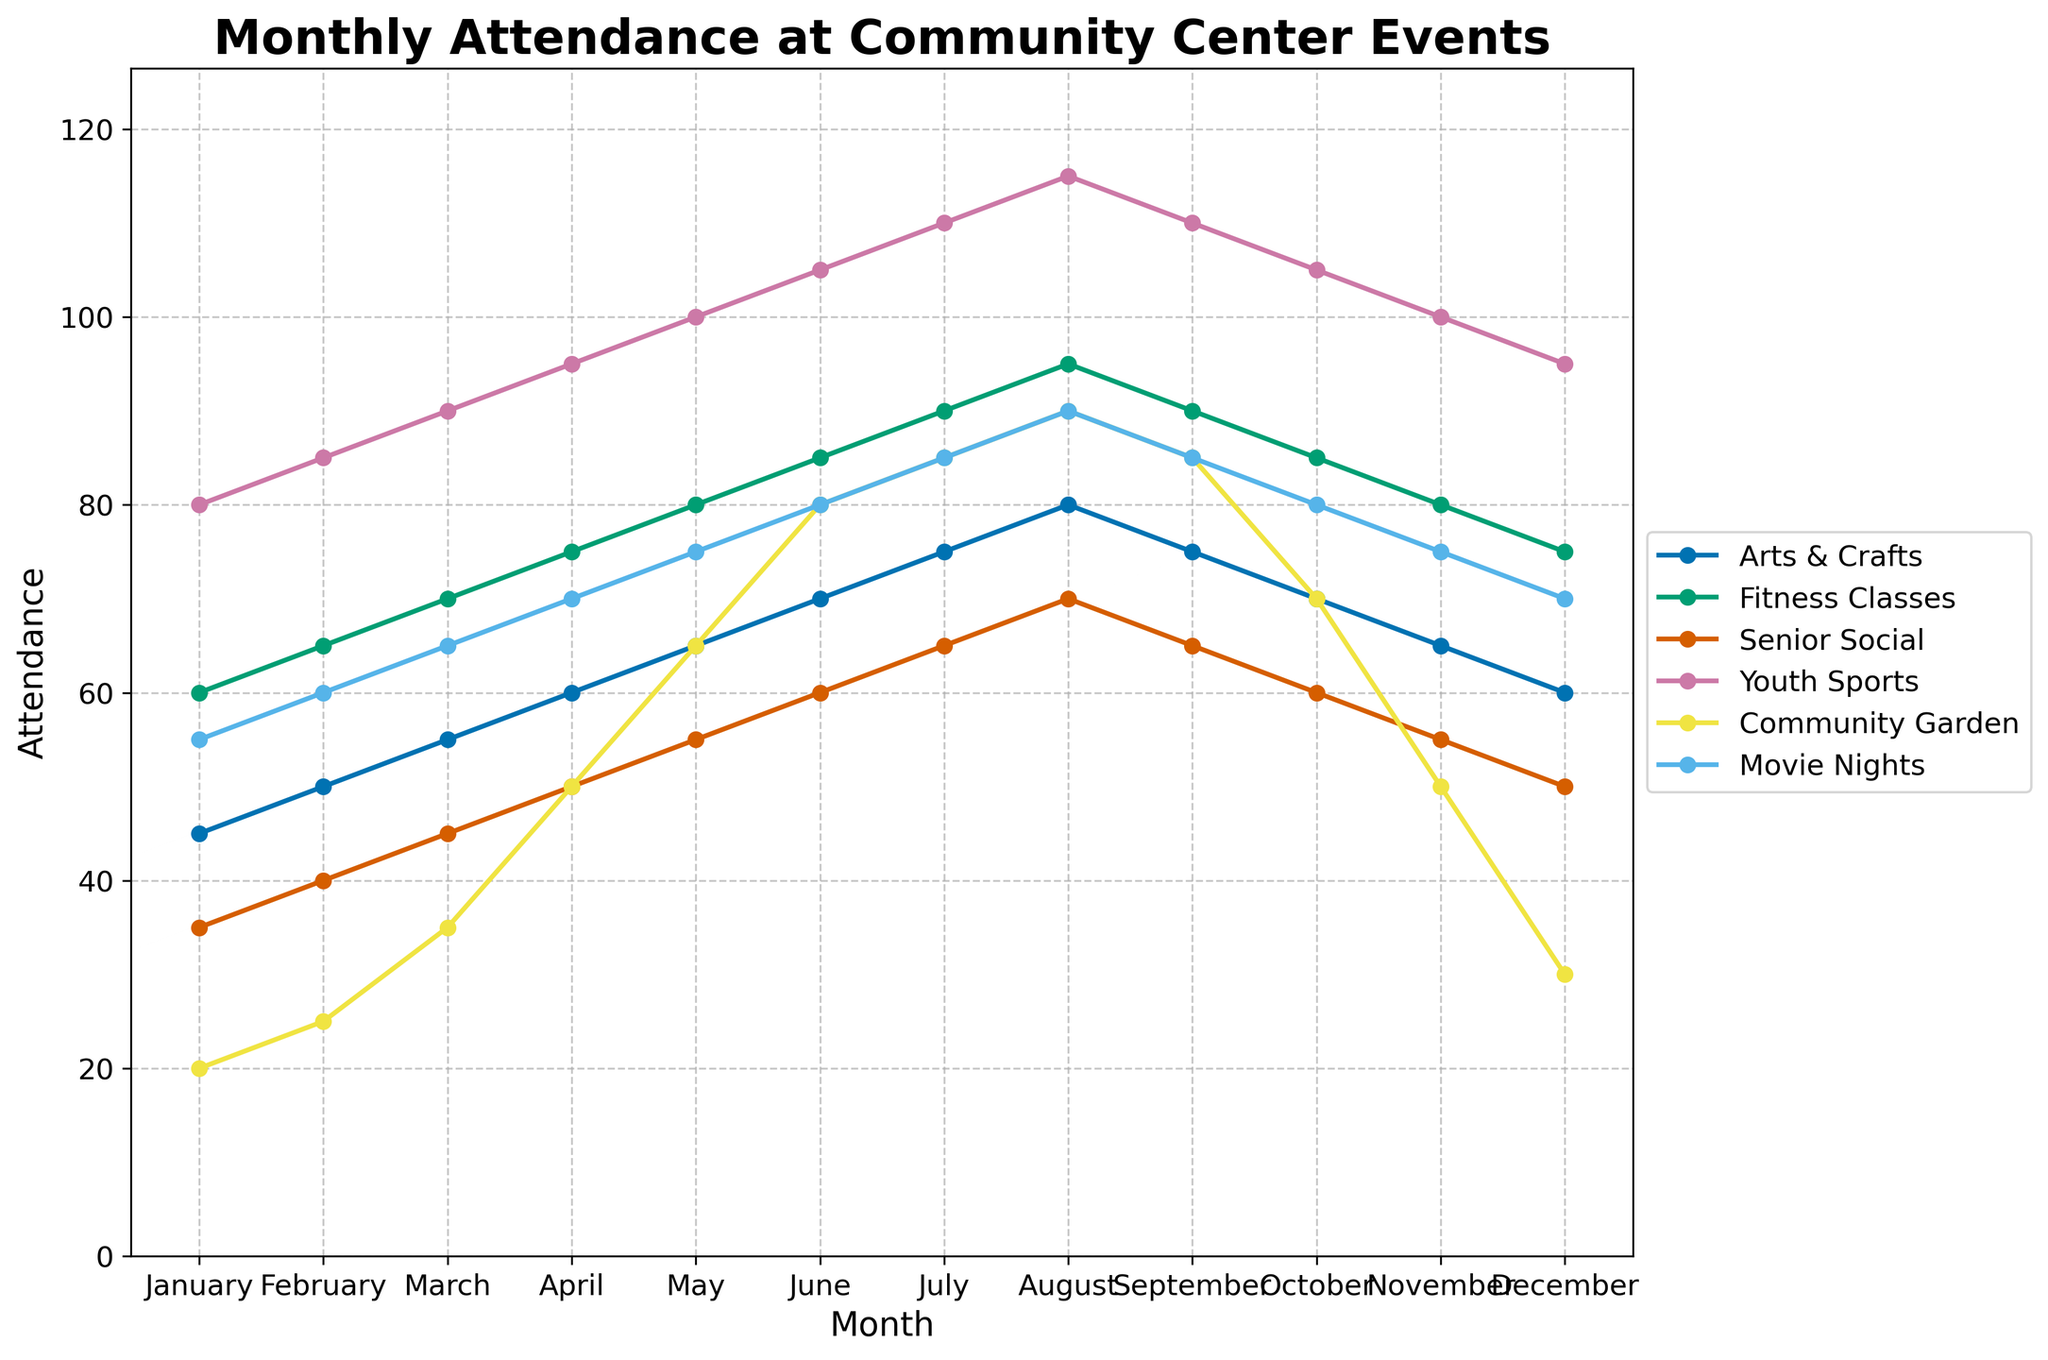Which activity had the highest attendance in August? By examining the lines on the plot, we see that the highest point in August is for "Youth Sports" with an attendance of 115.
Answer: Youth Sports Which activity shows the most significant increase in attendance from January to June? By comparing all activities from January to June, "Community Garden" shows the steepest increase from 20 to 80, an increase of 60.
Answer: Community Garden What is the average attendance for Fitness Classes over the year? Adding the attendance for each month: 60 + 65 + 70 + 75 + 80 + 85 + 90 + 95 + 90 + 85 + 80 + 75 = 950. Dividing by 12 months, the average is 950 / 12 = 79.17.
Answer: 79.17 How does the attendance for Movie Nights compare between February and November? Movie Nights attendance is 60 in February and 75 in November. The difference is 75 - 60 = 15, so there is an increase of 15 attendees.
Answer: November has 15 more attendees than February What is the average monthly attendance for Arts & Crafts and Senior Social combined? Adding each month's attendance for Arts & Crafts: 45 + 50 + 55 + 60 + 65 + 70 + 75 + 80 + 75 + 70 + 65 + 60 = 770. And for Senior Social: 35 + 40 + 45 + 50 + 55 + 60 + 65 + 70 + 65 + 60 + 55 + 50 = 650. The total combined attendance for both activities over the year is 770 + 650 = 1420. Dividing by 12 months, the average is 1420 / 12 = 118.33.
Answer: 118.33 Which activity had the lowest attendance in December? By examining the plot for December, "Community Garden" has the lowest point with an attendance of 30.
Answer: Community Garden Did any activity have the same attendance in both July and September? By checking the graph, "Arts & Crafts" and "Senior Social" both have the same attendance in July (75 and 65 respectively) and September (75 and 65 respectively).
Answer: Arts & Crafts and Senior Social Considering all activities, which month had the highest total attendance overall? Adding the attendance for all activities for each month, we get the totals. Finding the maximum sum, August has the highest total (80 + 95 + 70 + 115 + 90 + 90 = 540).
Answer: August Which activity had a steady attendance from July to September? By viewing the plot, "Youth Sports" had a consistent attendance of 110 in July, August, and September.
Answer: Youth Sports What is the range of attendance for Community Garden throughout the year? The highest attendance for Community Garden is 90 (August), and the lowest is 20 (January). The range is 90 - 20 = 70.
Answer: 70 